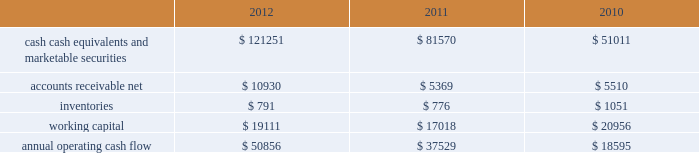35% ( 35 % ) due primarily to certain undistributed foreign earnings for which no u.s .
Taxes are provided because such earnings are intended to be indefinitely reinvested outside the u.s .
As of september 29 , 2012 , the company had deferred tax assets arising from deductible temporary differences , tax losses , and tax credits of $ 4.0 billion , and deferred tax liabilities of $ 14.9 billion .
Management believes it is more likely than not that forecasted income , including income that may be generated as a result of certain tax planning strategies , together with future reversals of existing taxable temporary differences , will be sufficient to fully recover the deferred tax assets .
The company will continue to evaluate the realizability of deferred tax assets quarterly by assessing the need for and amount of a valuation allowance .
The internal revenue service ( the 201cirs 201d ) has completed its field audit of the company 2019s federal income tax returns for the years 2004 through 2006 and proposed certain adjustments .
The company has contested certain of these adjustments through the irs appeals office .
The irs is currently examining the years 2007 through 2009 .
All irs audit issues for years prior to 2004 have been resolved .
In addition , the company is subject to audits by state , local , and foreign tax authorities .
Management believes that adequate provisions have been made for any adjustments that may result from tax examinations .
However , the outcome of tax audits cannot be predicted with certainty .
If any issues addressed in the company 2019s tax audits are resolved in a manner not consistent with management 2019s expectations , the company could be required to adjust its provision for income taxes in the period such resolution occurs .
Liquidity and capital resources the table presents selected financial information and statistics as of and for the years ended september 29 , 2012 , september 24 , 2011 , and september 25 , 2010 ( in millions ) : .
As of september 29 , 2012 , the company had $ 121.3 billion in cash , cash equivalents and marketable securities , an increase of $ 39.7 billion or 49% ( 49 % ) from september 24 , 2011 .
The principal components of this net increase was the cash generated by operating activities of $ 50.9 billion , which was partially offset by payments for acquisition of property , plant and equipment of $ 8.3 billion , payments for acquisition of intangible assets of $ 1.1 billion and payments of dividends and dividend equivalent rights of $ 2.5 billion .
The company 2019s marketable securities investment portfolio is invested primarily in highly-rated securities and its investment policy generally limits the amount of credit exposure to any one issuer .
The policy requires investments generally to be investment grade with the objective of minimizing the potential risk of principal loss .
As of september 29 , 2012 and september 24 , 2011 , $ 82.6 billion and $ 54.3 billion , respectively , of the company 2019s cash , cash equivalents and marketable securities were held by foreign subsidiaries and are generally based in u.s .
Dollar-denominated holdings .
Amounts held by foreign subsidiaries are generally subject to u.s .
Income taxation on repatriation to the u.s .
The company believes its existing balances of cash , cash equivalents and marketable securities will be sufficient to satisfy its working capital needs , capital asset purchases , outstanding commitments , common stock repurchases , dividends on its common stock , and other liquidity requirements associated with its existing operations over the next 12 months .
Capital assets the company 2019s capital expenditures were $ 10.3 billion during 2012 , consisting of $ 865 million for retail store facilities and $ 9.5 billion for other capital expenditures , including product tooling and manufacturing process .
What was the percentage change in the annual operating cash flow between 2011 and 2012? 
Computations: ((50856 - 37529) / 37529)
Answer: 0.35511. 